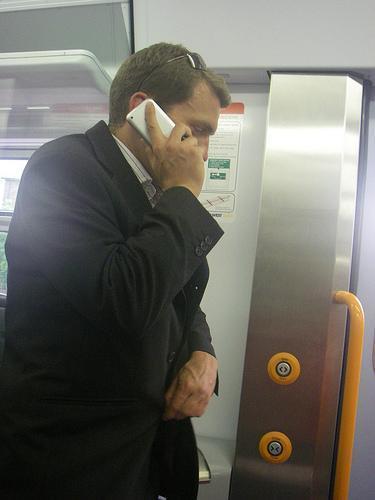How many phones are pictured?
Give a very brief answer. 1. 